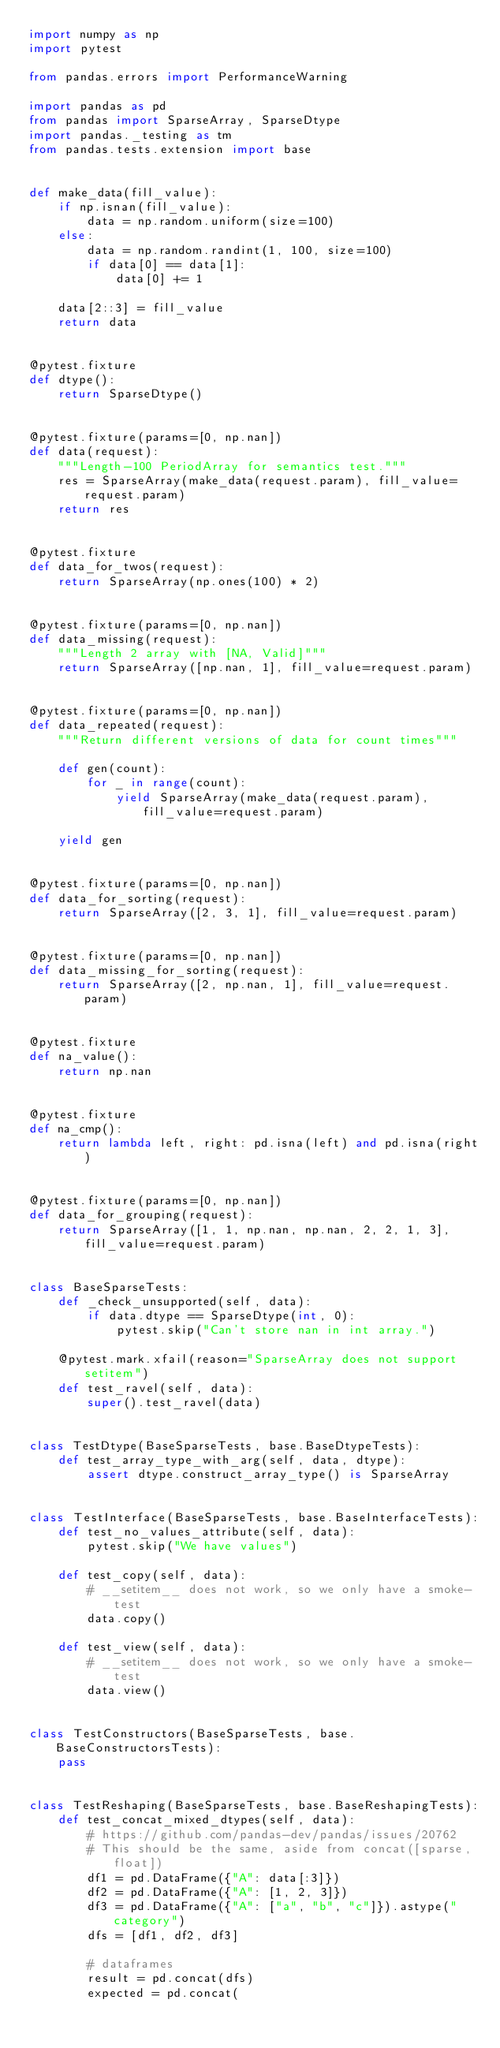Convert code to text. <code><loc_0><loc_0><loc_500><loc_500><_Python_>import numpy as np
import pytest

from pandas.errors import PerformanceWarning

import pandas as pd
from pandas import SparseArray, SparseDtype
import pandas._testing as tm
from pandas.tests.extension import base


def make_data(fill_value):
    if np.isnan(fill_value):
        data = np.random.uniform(size=100)
    else:
        data = np.random.randint(1, 100, size=100)
        if data[0] == data[1]:
            data[0] += 1

    data[2::3] = fill_value
    return data


@pytest.fixture
def dtype():
    return SparseDtype()


@pytest.fixture(params=[0, np.nan])
def data(request):
    """Length-100 PeriodArray for semantics test."""
    res = SparseArray(make_data(request.param), fill_value=request.param)
    return res


@pytest.fixture
def data_for_twos(request):
    return SparseArray(np.ones(100) * 2)


@pytest.fixture(params=[0, np.nan])
def data_missing(request):
    """Length 2 array with [NA, Valid]"""
    return SparseArray([np.nan, 1], fill_value=request.param)


@pytest.fixture(params=[0, np.nan])
def data_repeated(request):
    """Return different versions of data for count times"""

    def gen(count):
        for _ in range(count):
            yield SparseArray(make_data(request.param), fill_value=request.param)

    yield gen


@pytest.fixture(params=[0, np.nan])
def data_for_sorting(request):
    return SparseArray([2, 3, 1], fill_value=request.param)


@pytest.fixture(params=[0, np.nan])
def data_missing_for_sorting(request):
    return SparseArray([2, np.nan, 1], fill_value=request.param)


@pytest.fixture
def na_value():
    return np.nan


@pytest.fixture
def na_cmp():
    return lambda left, right: pd.isna(left) and pd.isna(right)


@pytest.fixture(params=[0, np.nan])
def data_for_grouping(request):
    return SparseArray([1, 1, np.nan, np.nan, 2, 2, 1, 3], fill_value=request.param)


class BaseSparseTests:
    def _check_unsupported(self, data):
        if data.dtype == SparseDtype(int, 0):
            pytest.skip("Can't store nan in int array.")

    @pytest.mark.xfail(reason="SparseArray does not support setitem")
    def test_ravel(self, data):
        super().test_ravel(data)


class TestDtype(BaseSparseTests, base.BaseDtypeTests):
    def test_array_type_with_arg(self, data, dtype):
        assert dtype.construct_array_type() is SparseArray


class TestInterface(BaseSparseTests, base.BaseInterfaceTests):
    def test_no_values_attribute(self, data):
        pytest.skip("We have values")

    def test_copy(self, data):
        # __setitem__ does not work, so we only have a smoke-test
        data.copy()

    def test_view(self, data):
        # __setitem__ does not work, so we only have a smoke-test
        data.view()


class TestConstructors(BaseSparseTests, base.BaseConstructorsTests):
    pass


class TestReshaping(BaseSparseTests, base.BaseReshapingTests):
    def test_concat_mixed_dtypes(self, data):
        # https://github.com/pandas-dev/pandas/issues/20762
        # This should be the same, aside from concat([sparse, float])
        df1 = pd.DataFrame({"A": data[:3]})
        df2 = pd.DataFrame({"A": [1, 2, 3]})
        df3 = pd.DataFrame({"A": ["a", "b", "c"]}).astype("category")
        dfs = [df1, df2, df3]

        # dataframes
        result = pd.concat(dfs)
        expected = pd.concat(</code> 